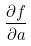Convert formula to latex. <formula><loc_0><loc_0><loc_500><loc_500>\frac { \partial f } { \partial a }</formula> 